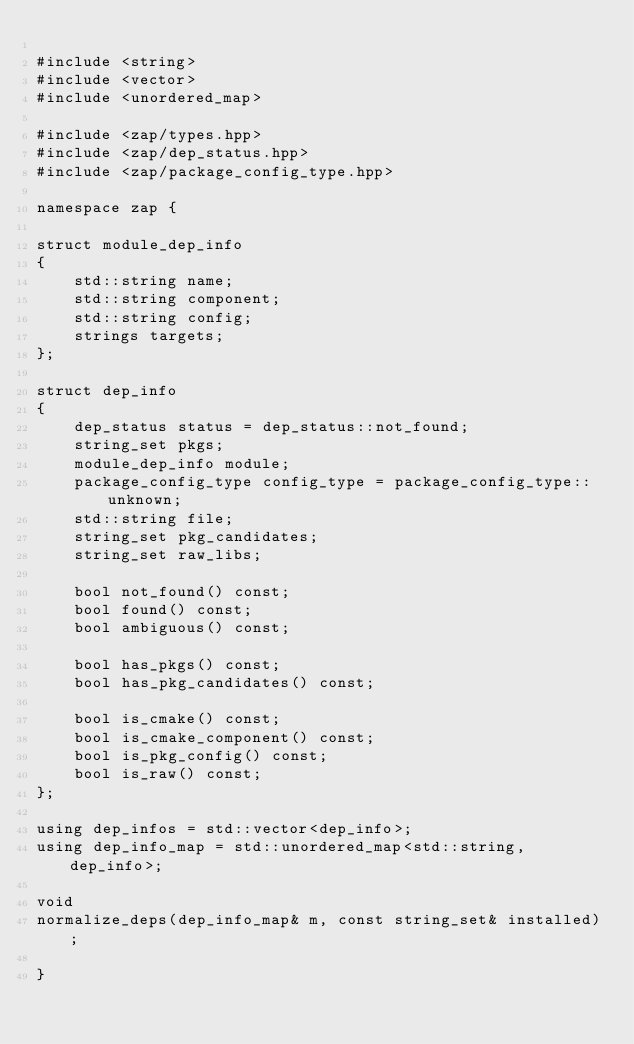Convert code to text. <code><loc_0><loc_0><loc_500><loc_500><_C++_>
#include <string>
#include <vector>
#include <unordered_map>

#include <zap/types.hpp>
#include <zap/dep_status.hpp>
#include <zap/package_config_type.hpp>

namespace zap {

struct module_dep_info
{
    std::string name;
    std::string component;
    std::string config;
    strings targets;
};

struct dep_info
{
    dep_status status = dep_status::not_found;
    string_set pkgs;
    module_dep_info module;
    package_config_type config_type = package_config_type::unknown;
    std::string file;
    string_set pkg_candidates;
    string_set raw_libs;

    bool not_found() const;
    bool found() const;
    bool ambiguous() const;

    bool has_pkgs() const;
    bool has_pkg_candidates() const;

    bool is_cmake() const;
    bool is_cmake_component() const;
    bool is_pkg_config() const;
    bool is_raw() const;
};

using dep_infos = std::vector<dep_info>;
using dep_info_map = std::unordered_map<std::string, dep_info>;

void
normalize_deps(dep_info_map& m, const string_set& installed);

}
</code> 